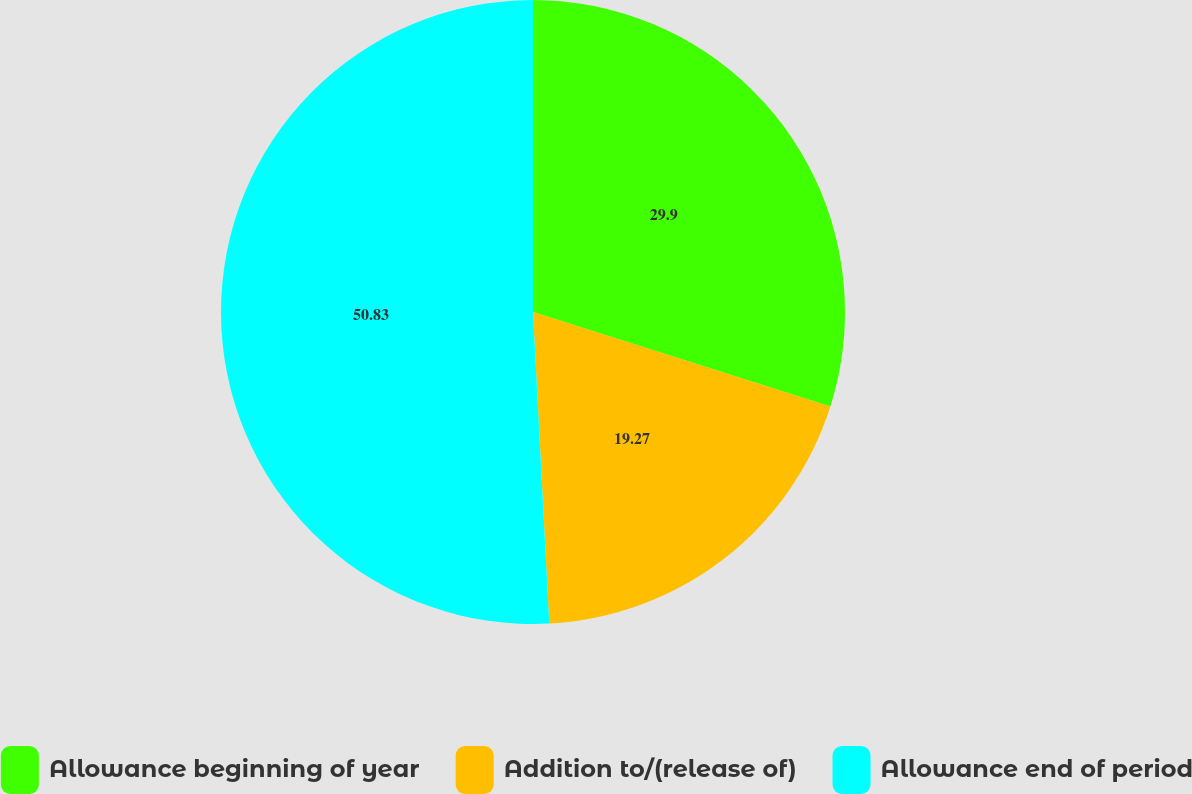Convert chart. <chart><loc_0><loc_0><loc_500><loc_500><pie_chart><fcel>Allowance beginning of year<fcel>Addition to/(release of)<fcel>Allowance end of period<nl><fcel>29.9%<fcel>19.27%<fcel>50.83%<nl></chart> 